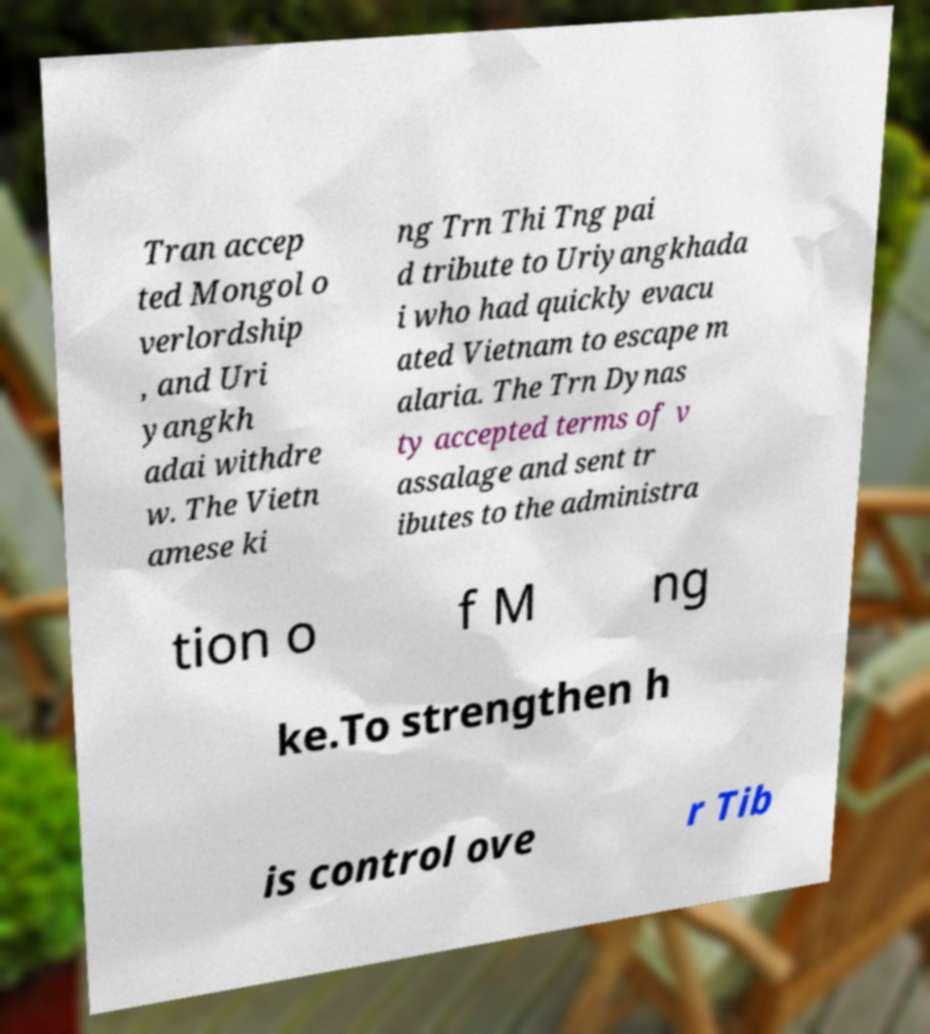I need the written content from this picture converted into text. Can you do that? Tran accep ted Mongol o verlordship , and Uri yangkh adai withdre w. The Vietn amese ki ng Trn Thi Tng pai d tribute to Uriyangkhada i who had quickly evacu ated Vietnam to escape m alaria. The Trn Dynas ty accepted terms of v assalage and sent tr ibutes to the administra tion o f M ng ke.To strengthen h is control ove r Tib 